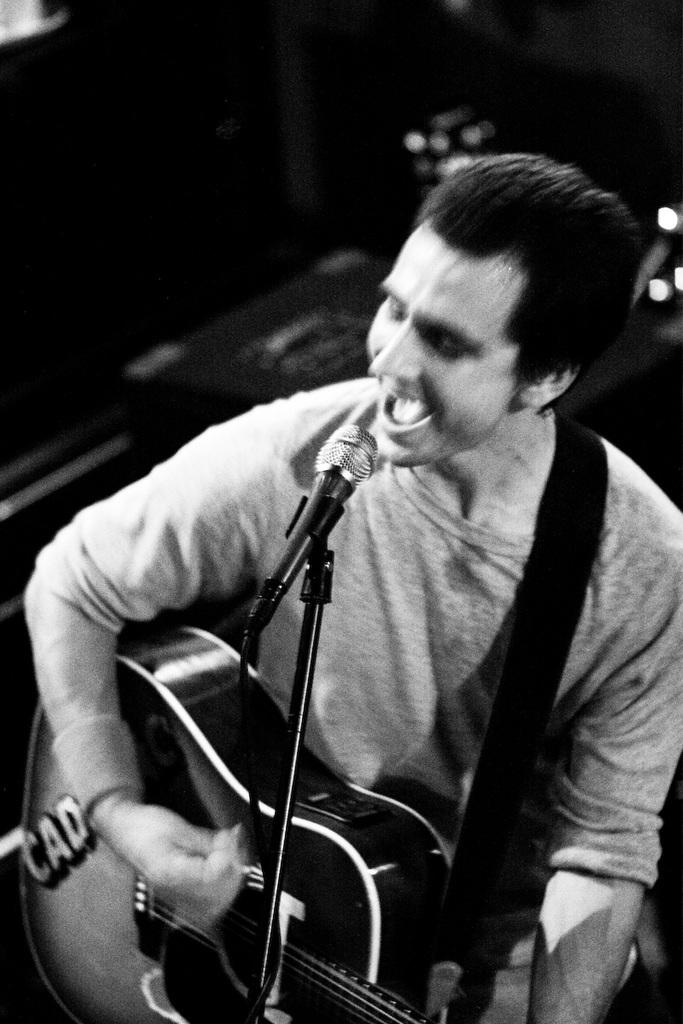What is the person in the image doing? The person is playing the guitar and singing. What instrument is the person holding? The person is holding a guitar. What is in front of the person to help amplify their voice? There is a microphone and a mic stand in front of the person. How many yams are being held by the person in the image? There are no yams present in the image; the person is holding a guitar. What type of horse is visible in the image? There are no horses present in the image; the person is playing the guitar and singing. 